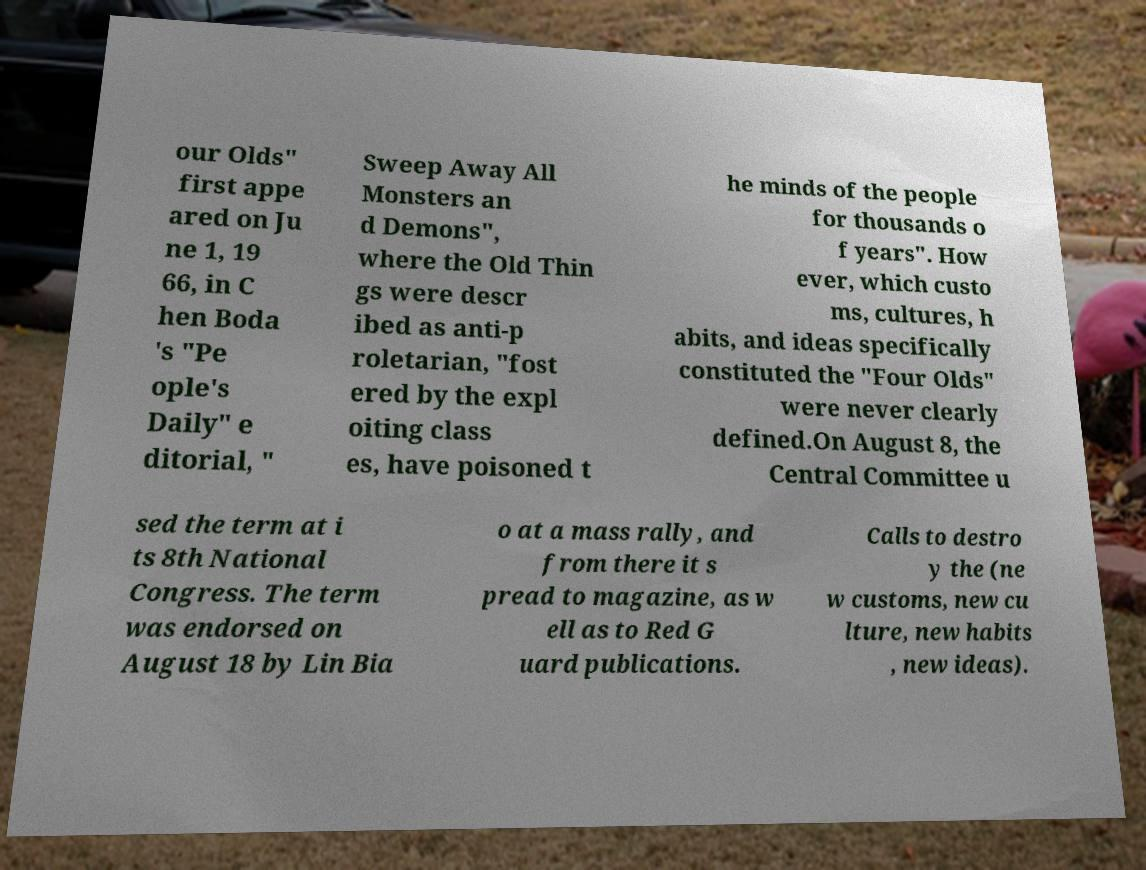What messages or text are displayed in this image? I need them in a readable, typed format. our Olds" first appe ared on Ju ne 1, 19 66, in C hen Boda 's "Pe ople's Daily" e ditorial, " Sweep Away All Monsters an d Demons", where the Old Thin gs were descr ibed as anti-p roletarian, "fost ered by the expl oiting class es, have poisoned t he minds of the people for thousands o f years". How ever, which custo ms, cultures, h abits, and ideas specifically constituted the "Four Olds" were never clearly defined.On August 8, the Central Committee u sed the term at i ts 8th National Congress. The term was endorsed on August 18 by Lin Bia o at a mass rally, and from there it s pread to magazine, as w ell as to Red G uard publications. Calls to destro y the (ne w customs, new cu lture, new habits , new ideas). 